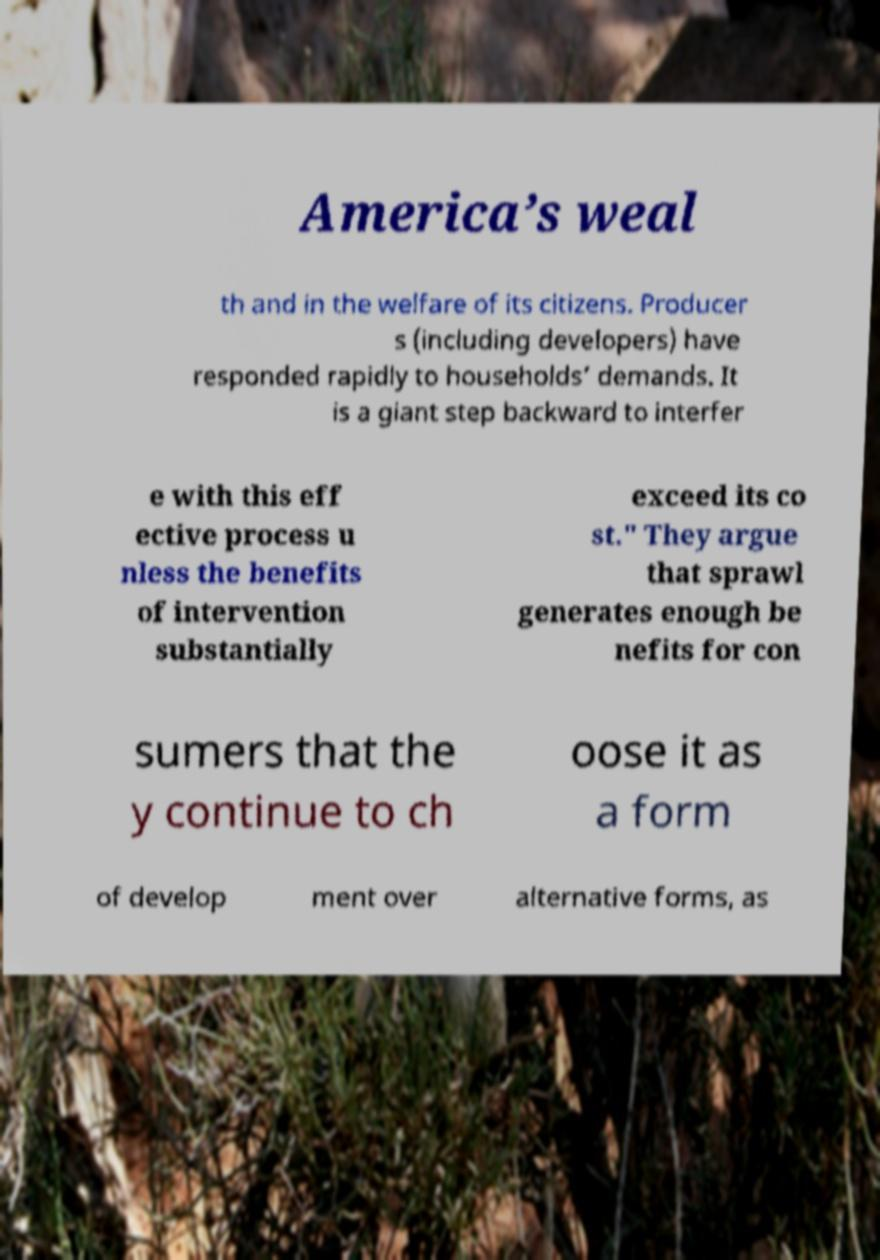Please read and relay the text visible in this image. What does it say? America’s weal th and in the welfare of its citizens. Producer s (including developers) have responded rapidly to households’ demands. It is a giant step backward to interfer e with this eff ective process u nless the benefits of intervention substantially exceed its co st." They argue that sprawl generates enough be nefits for con sumers that the y continue to ch oose it as a form of develop ment over alternative forms, as 